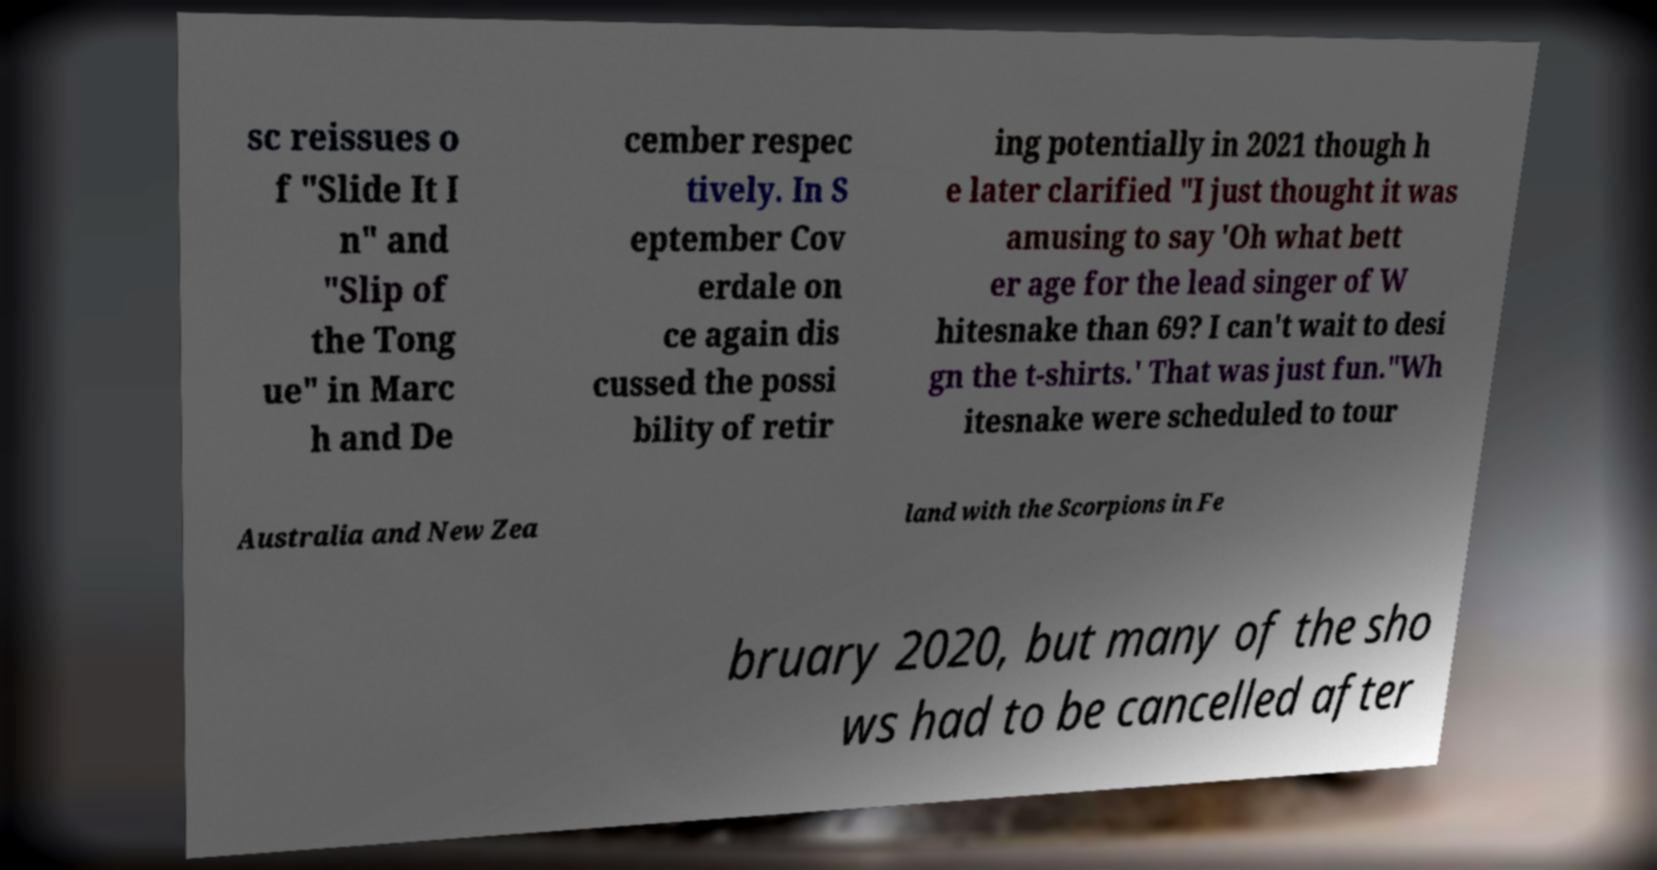I need the written content from this picture converted into text. Can you do that? sc reissues o f "Slide It I n" and "Slip of the Tong ue" in Marc h and De cember respec tively. In S eptember Cov erdale on ce again dis cussed the possi bility of retir ing potentially in 2021 though h e later clarified "I just thought it was amusing to say 'Oh what bett er age for the lead singer of W hitesnake than 69? I can't wait to desi gn the t-shirts.' That was just fun."Wh itesnake were scheduled to tour Australia and New Zea land with the Scorpions in Fe bruary 2020, but many of the sho ws had to be cancelled after 